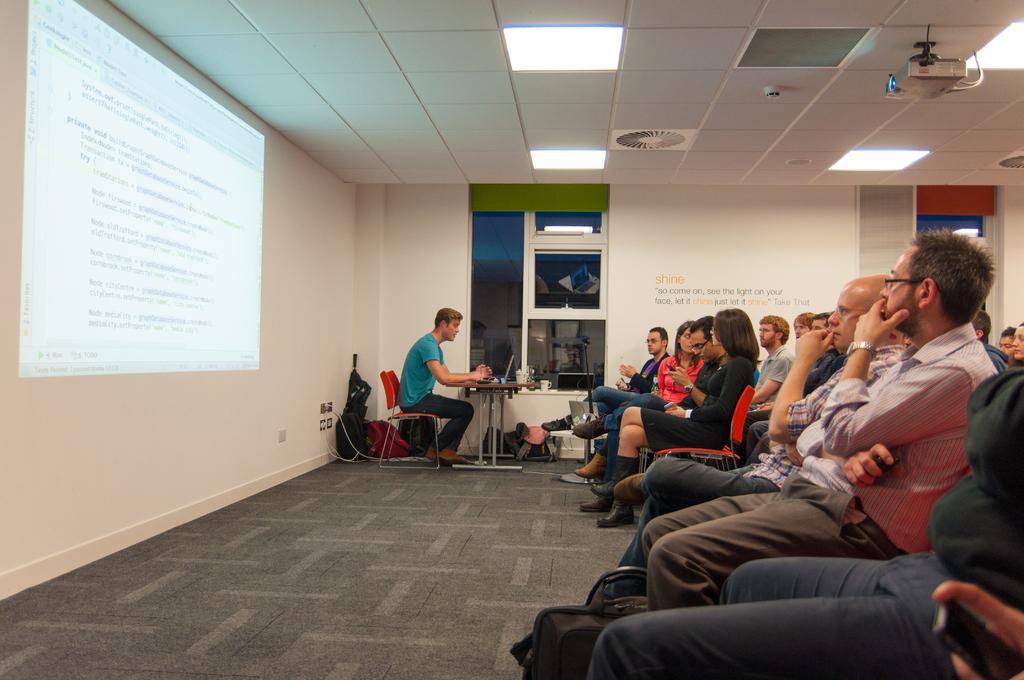Describe this image in one or two sentences. There are many people sitting on chairs. In the corner a person wearing a blue dress is sitting on a chair. In front of him there is a table. On the table there is a laptop. In the background there is wall. On the wall the is a screen, window. Near the window there is a cup. Also there are wires and sockets in the wall. On the floor there are bags. In the ceiling there is a projector and lights. 